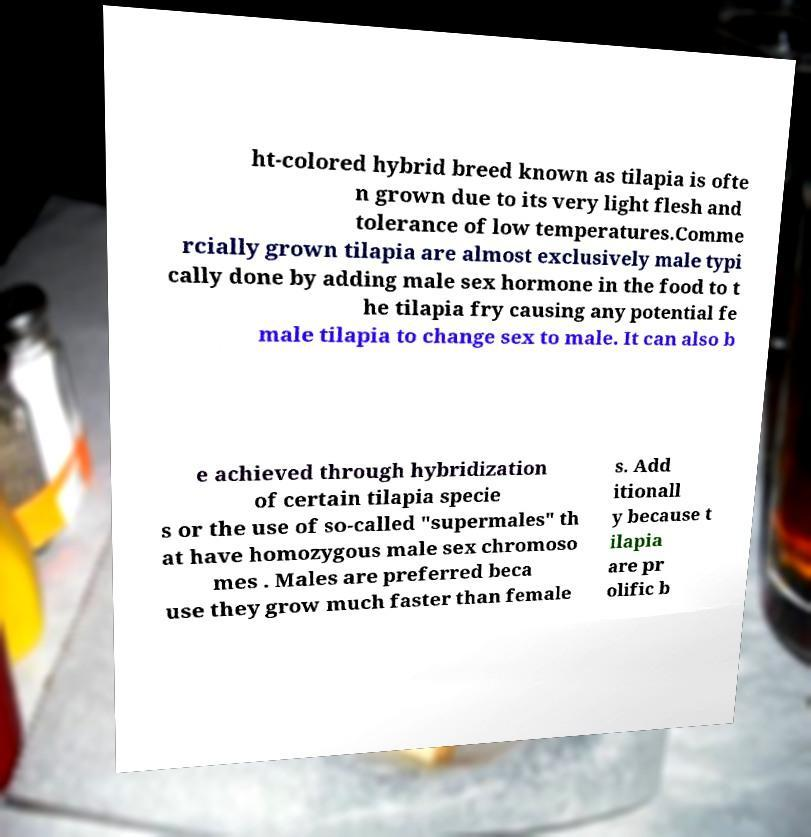Please read and relay the text visible in this image. What does it say? ht-colored hybrid breed known as tilapia is ofte n grown due to its very light flesh and tolerance of low temperatures.Comme rcially grown tilapia are almost exclusively male typi cally done by adding male sex hormone in the food to t he tilapia fry causing any potential fe male tilapia to change sex to male. It can also b e achieved through hybridization of certain tilapia specie s or the use of so-called "supermales" th at have homozygous male sex chromoso mes . Males are preferred beca use they grow much faster than female s. Add itionall y because t ilapia are pr olific b 